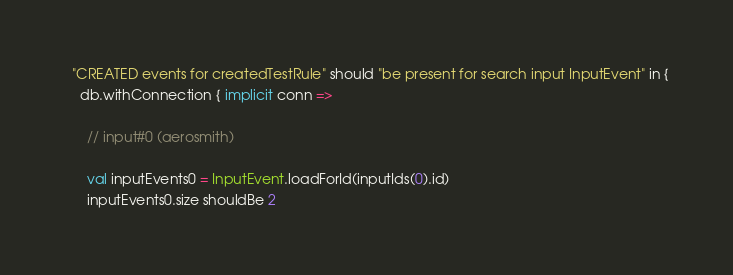Convert code to text. <code><loc_0><loc_0><loc_500><loc_500><_Scala_>  "CREATED events for createdTestRule" should "be present for search input InputEvent" in {
    db.withConnection { implicit conn =>

      // input#0 (aerosmith)

      val inputEvents0 = InputEvent.loadForId(inputIds(0).id)
      inputEvents0.size shouldBe 2
</code> 